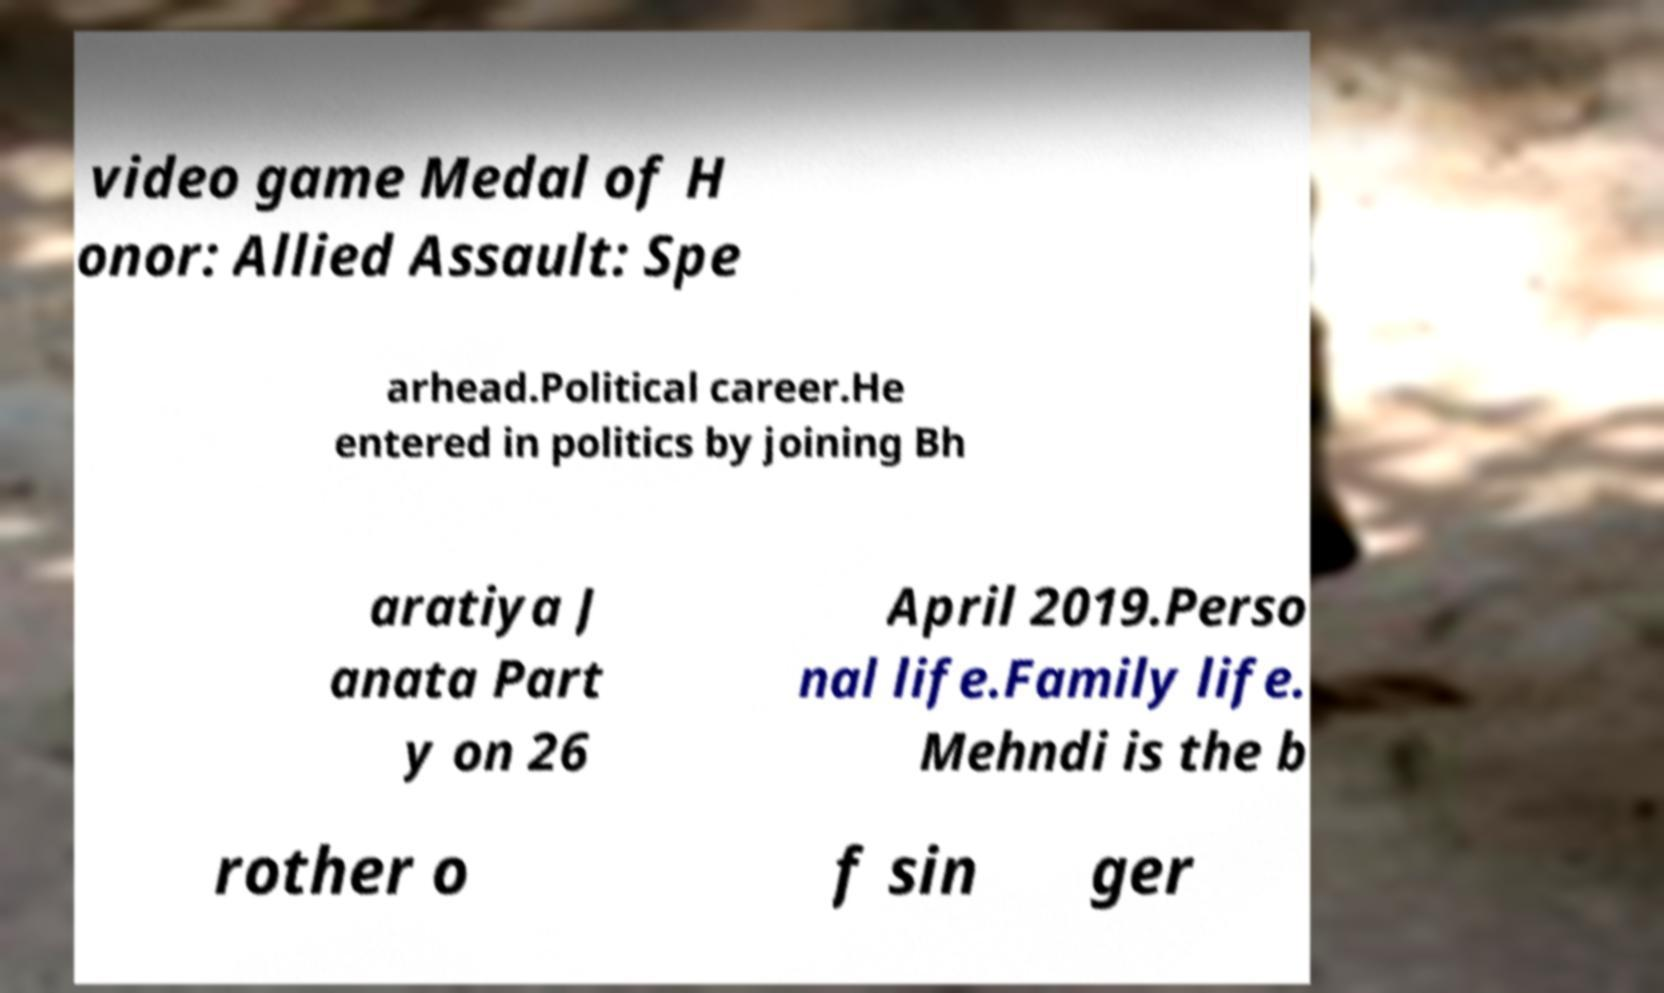Please read and relay the text visible in this image. What does it say? video game Medal of H onor: Allied Assault: Spe arhead.Political career.He entered in politics by joining Bh aratiya J anata Part y on 26 April 2019.Perso nal life.Family life. Mehndi is the b rother o f sin ger 